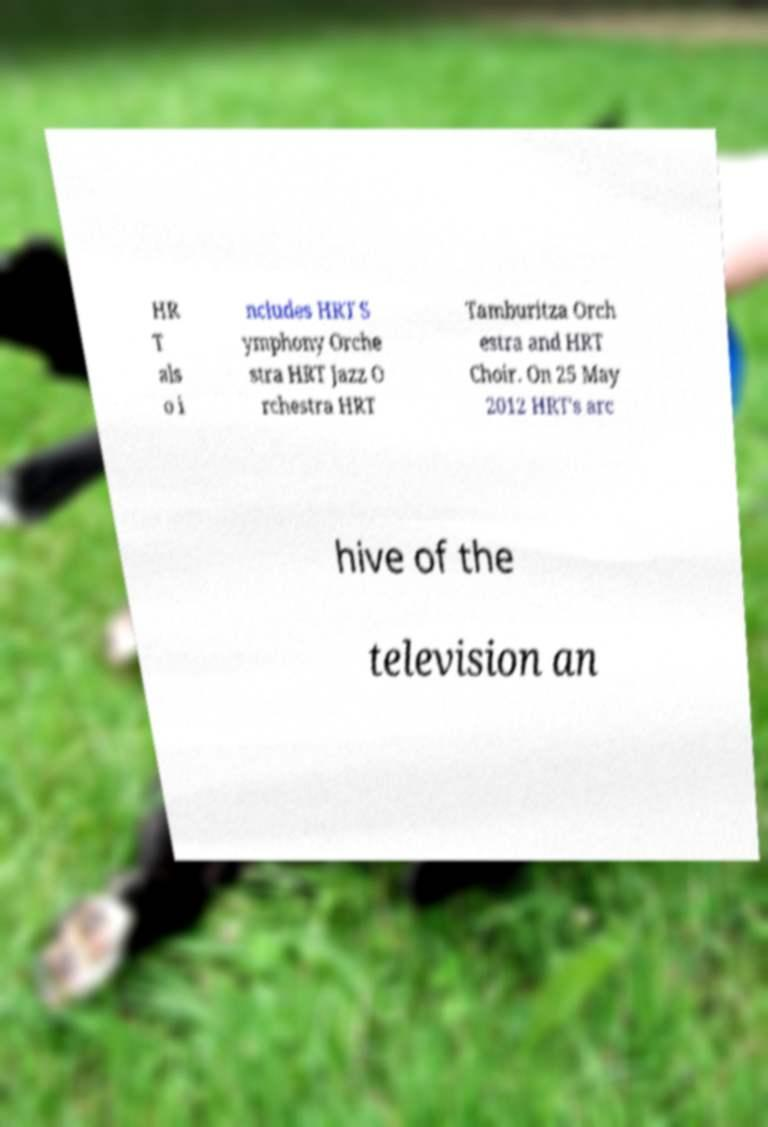Could you assist in decoding the text presented in this image and type it out clearly? HR T als o i ncludes HRT S ymphony Orche stra HRT Jazz O rchestra HRT Tamburitza Orch estra and HRT Choir. On 25 May 2012 HRT's arc hive of the television an 